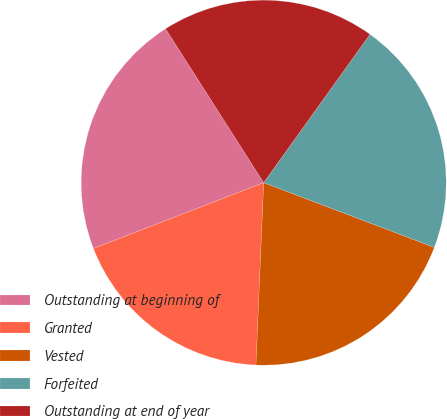Convert chart. <chart><loc_0><loc_0><loc_500><loc_500><pie_chart><fcel>Outstanding at beginning of<fcel>Granted<fcel>Vested<fcel>Forfeited<fcel>Outstanding at end of year<nl><fcel>21.84%<fcel>18.45%<fcel>19.9%<fcel>20.87%<fcel>18.93%<nl></chart> 